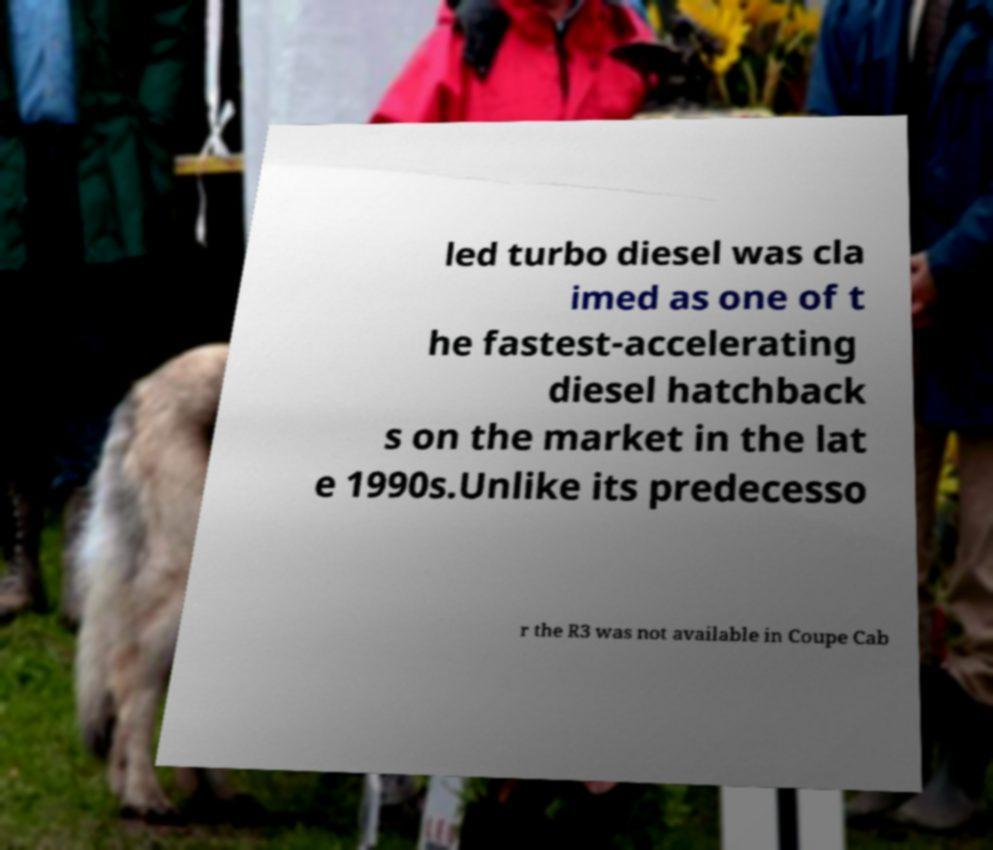Please read and relay the text visible in this image. What does it say? led turbo diesel was cla imed as one of t he fastest-accelerating diesel hatchback s on the market in the lat e 1990s.Unlike its predecesso r the R3 was not available in Coupe Cab 